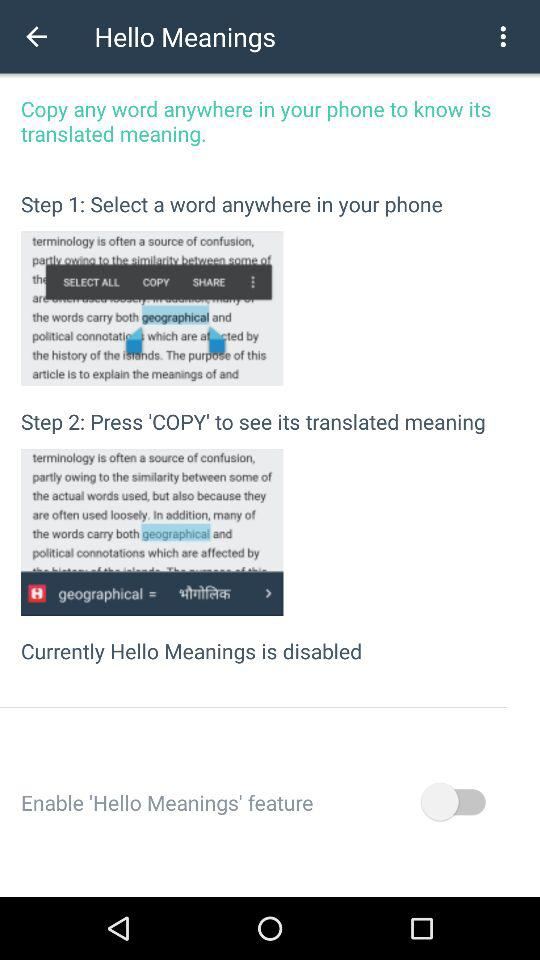What button do we have to press to see the translated meaning? You have to press the 'COPY' button to see the translated meaning. 